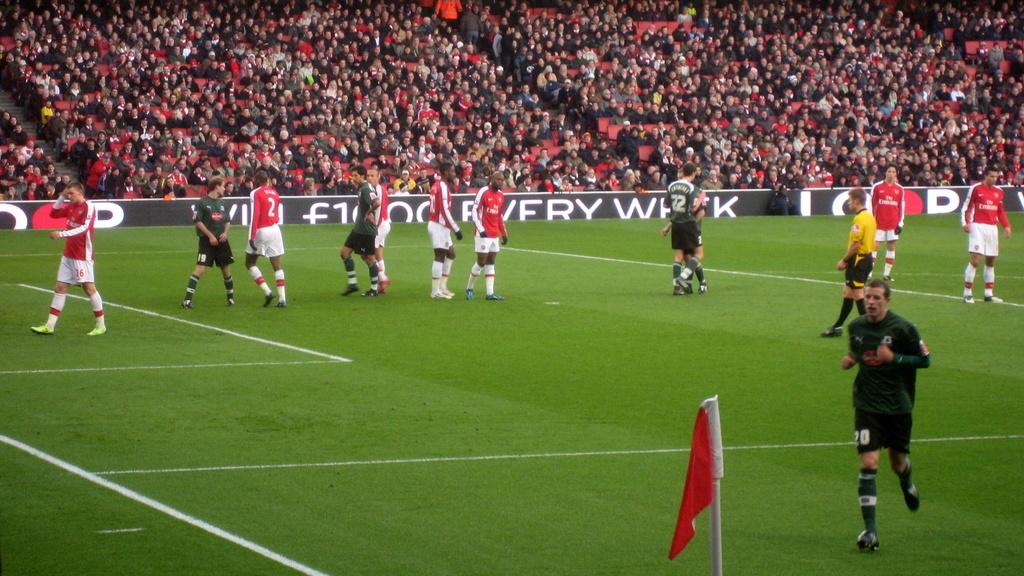<image>
Give a short and clear explanation of the subsequent image. A soccer field with a group of players in red jersey's with Fly Emirates on them facing players in green jerseys. 